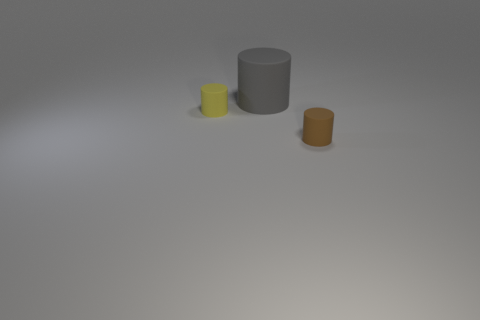How many spheres are small yellow rubber objects or tiny cyan metallic objects?
Keep it short and to the point. 0. There is a matte thing that is in front of the tiny yellow object; is it the same shape as the gray thing?
Offer a very short reply. Yes. Are there more matte cylinders that are behind the yellow rubber thing than tiny balls?
Your answer should be compact. Yes. There is another rubber cylinder that is the same size as the yellow cylinder; what color is it?
Give a very brief answer. Brown. What number of things are either small things that are in front of the tiny yellow cylinder or gray matte things?
Your response must be concise. 2. What material is the brown object on the right side of the rubber object left of the large gray cylinder?
Ensure brevity in your answer.  Rubber. Are there any things made of the same material as the large cylinder?
Your response must be concise. Yes. There is a cylinder that is left of the gray rubber cylinder; are there any large gray cylinders that are behind it?
Your response must be concise. Yes. What material is the small cylinder that is behind the brown matte cylinder?
Give a very brief answer. Rubber. Do the big gray matte thing and the small brown object have the same shape?
Keep it short and to the point. Yes. 